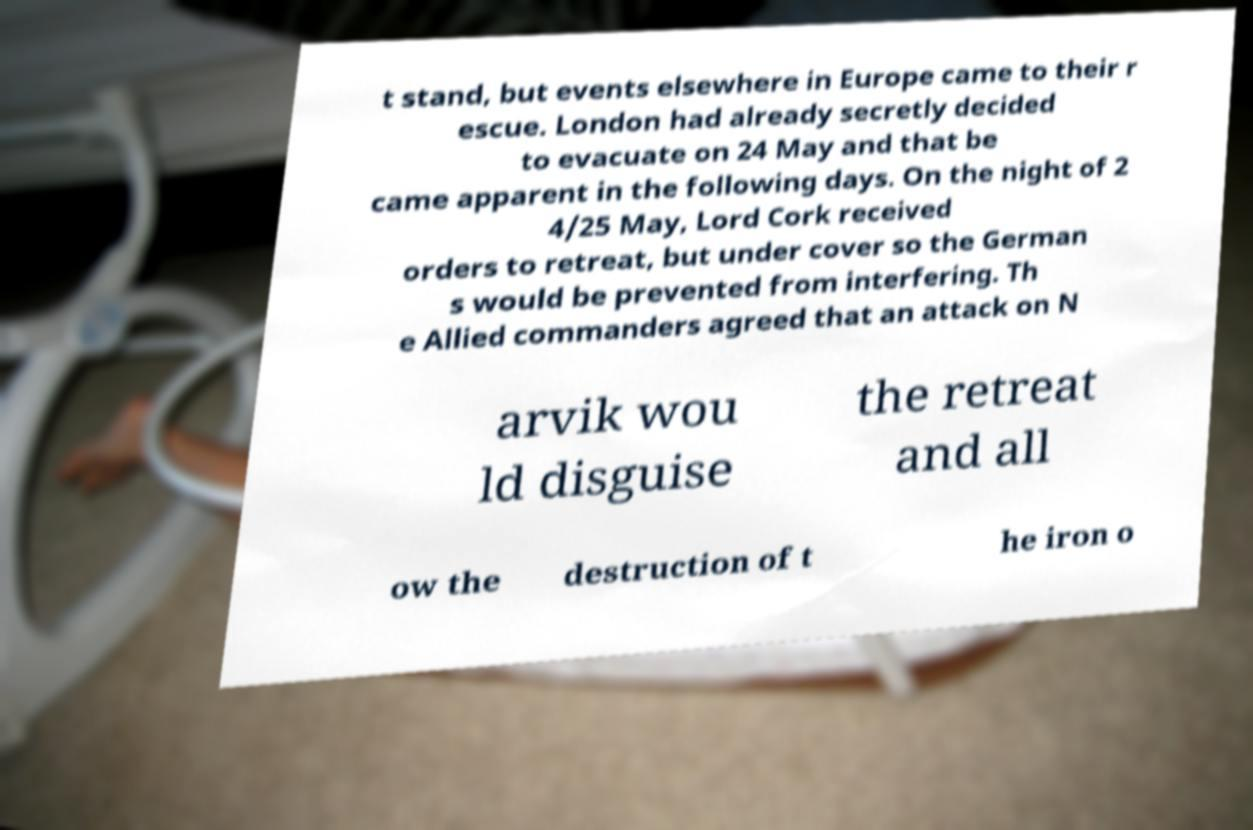Can you read and provide the text displayed in the image?This photo seems to have some interesting text. Can you extract and type it out for me? t stand, but events elsewhere in Europe came to their r escue. London had already secretly decided to evacuate on 24 May and that be came apparent in the following days. On the night of 2 4/25 May, Lord Cork received orders to retreat, but under cover so the German s would be prevented from interfering. Th e Allied commanders agreed that an attack on N arvik wou ld disguise the retreat and all ow the destruction of t he iron o 